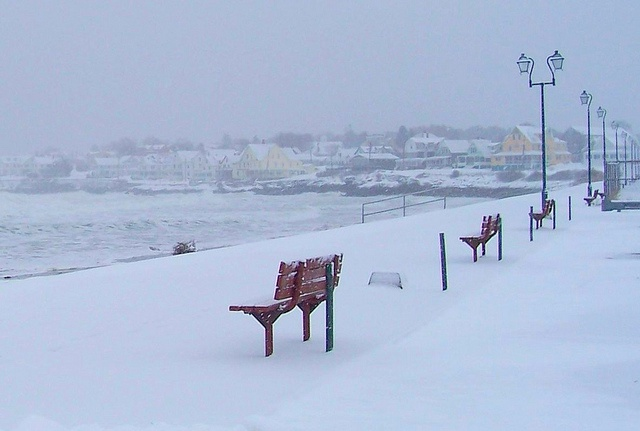Describe the objects in this image and their specific colors. I can see bench in darkgray, purple, and black tones, bench in darkgray, gray, purple, and lavender tones, bench in darkgray, gray, navy, and black tones, bench in darkgray, gray, navy, lavender, and blue tones, and bench in darkgray, navy, purple, and darkblue tones in this image. 